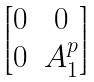Convert formula to latex. <formula><loc_0><loc_0><loc_500><loc_500>\begin{bmatrix} 0 & 0 \\ 0 & A _ { 1 } ^ { p } \end{bmatrix}</formula> 